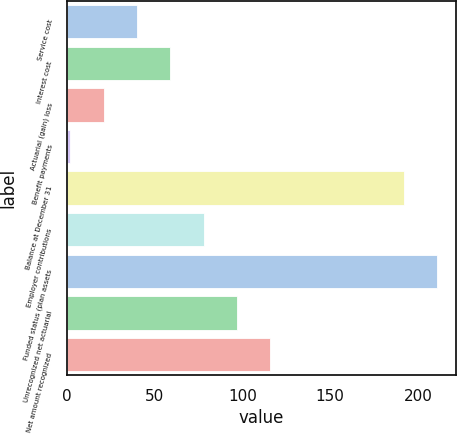Convert chart. <chart><loc_0><loc_0><loc_500><loc_500><bar_chart><fcel>Service cost<fcel>Interest cost<fcel>Actuarial (gain) loss<fcel>Benefit payments<fcel>Balance at December 31<fcel>Employer contributions<fcel>Funded status (plan assets<fcel>Unrecognized net actuarial<fcel>Net amount recognized<nl><fcel>40<fcel>59<fcel>21<fcel>2<fcel>192<fcel>78<fcel>211<fcel>97<fcel>116<nl></chart> 